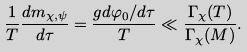<formula> <loc_0><loc_0><loc_500><loc_500>\frac { 1 } { T } \frac { d m _ { \chi , \psi } } { d \tau } = \frac { g d \varphi _ { 0 } / d \tau } { T } \ll \frac { \Gamma _ { \chi } ( T ) } { \Gamma _ { \chi } ( M ) } .</formula> 